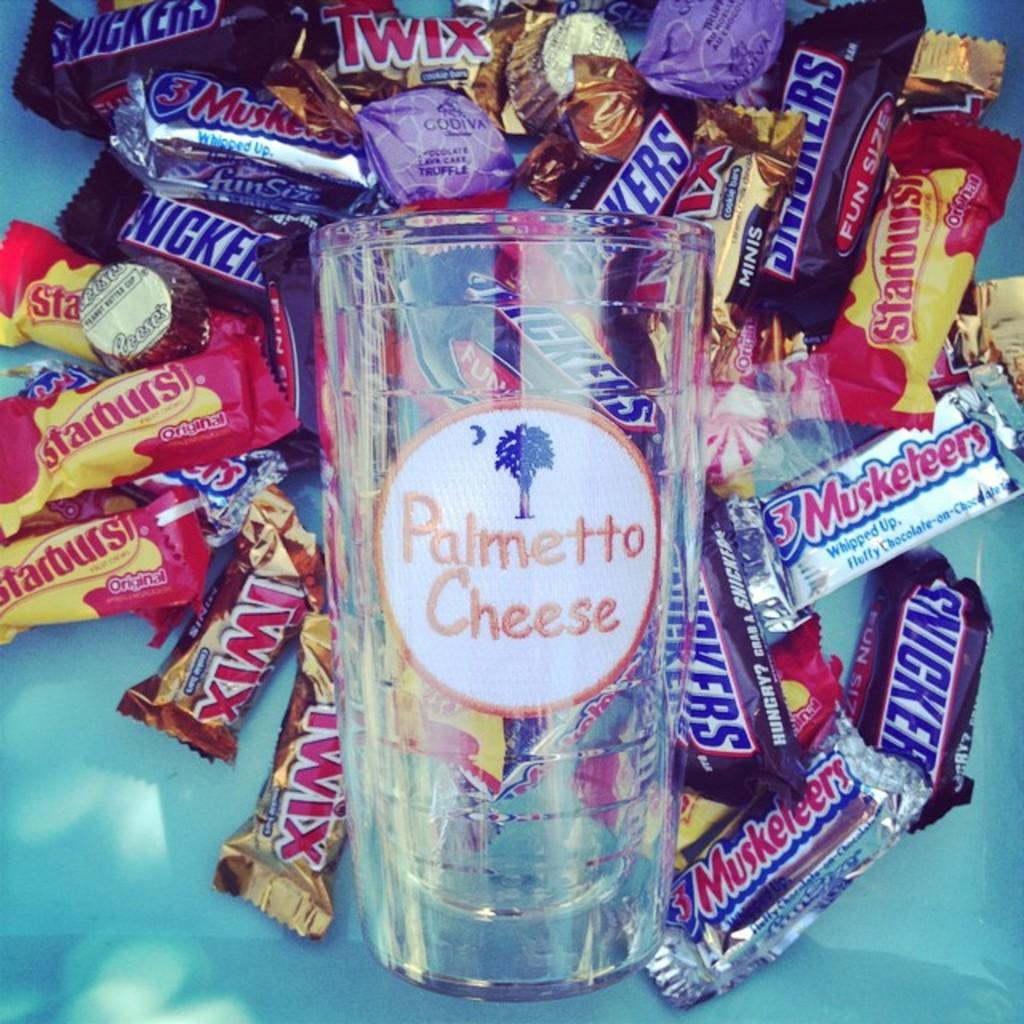What type of food is present in the image? There are chocolates in the image. Where are the chocolates located in the image? The chocolates are in the middle of the image. What else can be seen in the middle of the image? There is a glass in the middle of the image. Can you describe the glass in the image? The glass is present in the image, but its characteristics are not mentioned in the provided facts. What type of hole can be seen in the image? There is no hole present in the image. How many pockets are visible in the image? There is no mention of pockets in the provided facts, so it cannot be determined if any are visible in the image. 